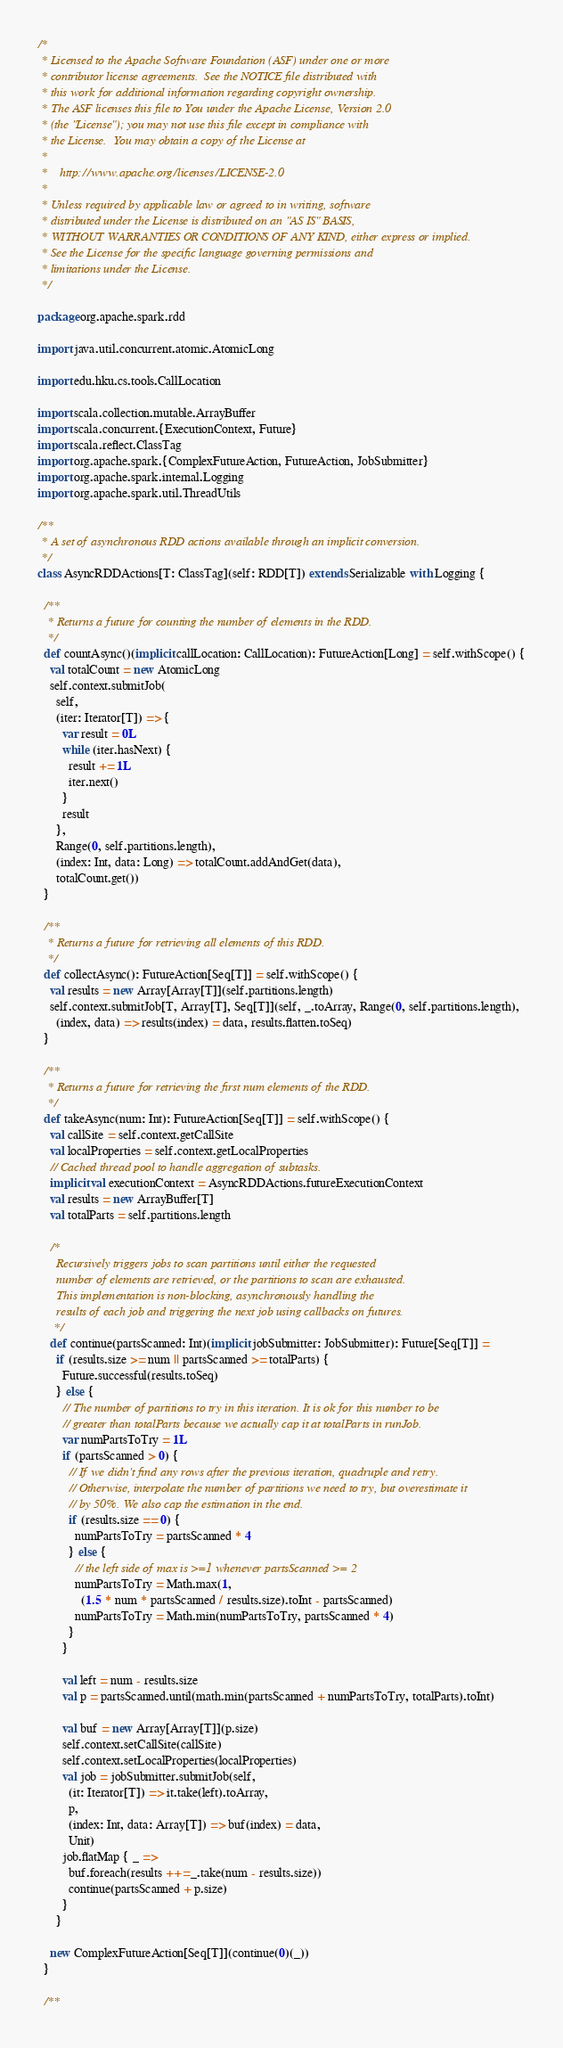<code> <loc_0><loc_0><loc_500><loc_500><_Scala_>/*
 * Licensed to the Apache Software Foundation (ASF) under one or more
 * contributor license agreements.  See the NOTICE file distributed with
 * this work for additional information regarding copyright ownership.
 * The ASF licenses this file to You under the Apache License, Version 2.0
 * (the "License"); you may not use this file except in compliance with
 * the License.  You may obtain a copy of the License at
 *
 *    http://www.apache.org/licenses/LICENSE-2.0
 *
 * Unless required by applicable law or agreed to in writing, software
 * distributed under the License is distributed on an "AS IS" BASIS,
 * WITHOUT WARRANTIES OR CONDITIONS OF ANY KIND, either express or implied.
 * See the License for the specific language governing permissions and
 * limitations under the License.
 */

package org.apache.spark.rdd

import java.util.concurrent.atomic.AtomicLong

import edu.hku.cs.tools.CallLocation

import scala.collection.mutable.ArrayBuffer
import scala.concurrent.{ExecutionContext, Future}
import scala.reflect.ClassTag
import org.apache.spark.{ComplexFutureAction, FutureAction, JobSubmitter}
import org.apache.spark.internal.Logging
import org.apache.spark.util.ThreadUtils

/**
 * A set of asynchronous RDD actions available through an implicit conversion.
 */
class AsyncRDDActions[T: ClassTag](self: RDD[T]) extends Serializable with Logging {

  /**
   * Returns a future for counting the number of elements in the RDD.
   */
  def countAsync()(implicit callLocation: CallLocation): FutureAction[Long] = self.withScope() {
    val totalCount = new AtomicLong
    self.context.submitJob(
      self,
      (iter: Iterator[T]) => {
        var result = 0L
        while (iter.hasNext) {
          result += 1L
          iter.next()
        }
        result
      },
      Range(0, self.partitions.length),
      (index: Int, data: Long) => totalCount.addAndGet(data),
      totalCount.get())
  }

  /**
   * Returns a future for retrieving all elements of this RDD.
   */
  def collectAsync(): FutureAction[Seq[T]] = self.withScope() {
    val results = new Array[Array[T]](self.partitions.length)
    self.context.submitJob[T, Array[T], Seq[T]](self, _.toArray, Range(0, self.partitions.length),
      (index, data) => results(index) = data, results.flatten.toSeq)
  }

  /**
   * Returns a future for retrieving the first num elements of the RDD.
   */
  def takeAsync(num: Int): FutureAction[Seq[T]] = self.withScope() {
    val callSite = self.context.getCallSite
    val localProperties = self.context.getLocalProperties
    // Cached thread pool to handle aggregation of subtasks.
    implicit val executionContext = AsyncRDDActions.futureExecutionContext
    val results = new ArrayBuffer[T]
    val totalParts = self.partitions.length

    /*
      Recursively triggers jobs to scan partitions until either the requested
      number of elements are retrieved, or the partitions to scan are exhausted.
      This implementation is non-blocking, asynchronously handling the
      results of each job and triggering the next job using callbacks on futures.
     */
    def continue(partsScanned: Int)(implicit jobSubmitter: JobSubmitter): Future[Seq[T]] =
      if (results.size >= num || partsScanned >= totalParts) {
        Future.successful(results.toSeq)
      } else {
        // The number of partitions to try in this iteration. It is ok for this number to be
        // greater than totalParts because we actually cap it at totalParts in runJob.
        var numPartsToTry = 1L
        if (partsScanned > 0) {
          // If we didn't find any rows after the previous iteration, quadruple and retry.
          // Otherwise, interpolate the number of partitions we need to try, but overestimate it
          // by 50%. We also cap the estimation in the end.
          if (results.size == 0) {
            numPartsToTry = partsScanned * 4
          } else {
            // the left side of max is >=1 whenever partsScanned >= 2
            numPartsToTry = Math.max(1,
              (1.5 * num * partsScanned / results.size).toInt - partsScanned)
            numPartsToTry = Math.min(numPartsToTry, partsScanned * 4)
          }
        }

        val left = num - results.size
        val p = partsScanned.until(math.min(partsScanned + numPartsToTry, totalParts).toInt)

        val buf = new Array[Array[T]](p.size)
        self.context.setCallSite(callSite)
        self.context.setLocalProperties(localProperties)
        val job = jobSubmitter.submitJob(self,
          (it: Iterator[T]) => it.take(left).toArray,
          p,
          (index: Int, data: Array[T]) => buf(index) = data,
          Unit)
        job.flatMap { _ =>
          buf.foreach(results ++= _.take(num - results.size))
          continue(partsScanned + p.size)
        }
      }

    new ComplexFutureAction[Seq[T]](continue(0)(_))
  }

  /**</code> 